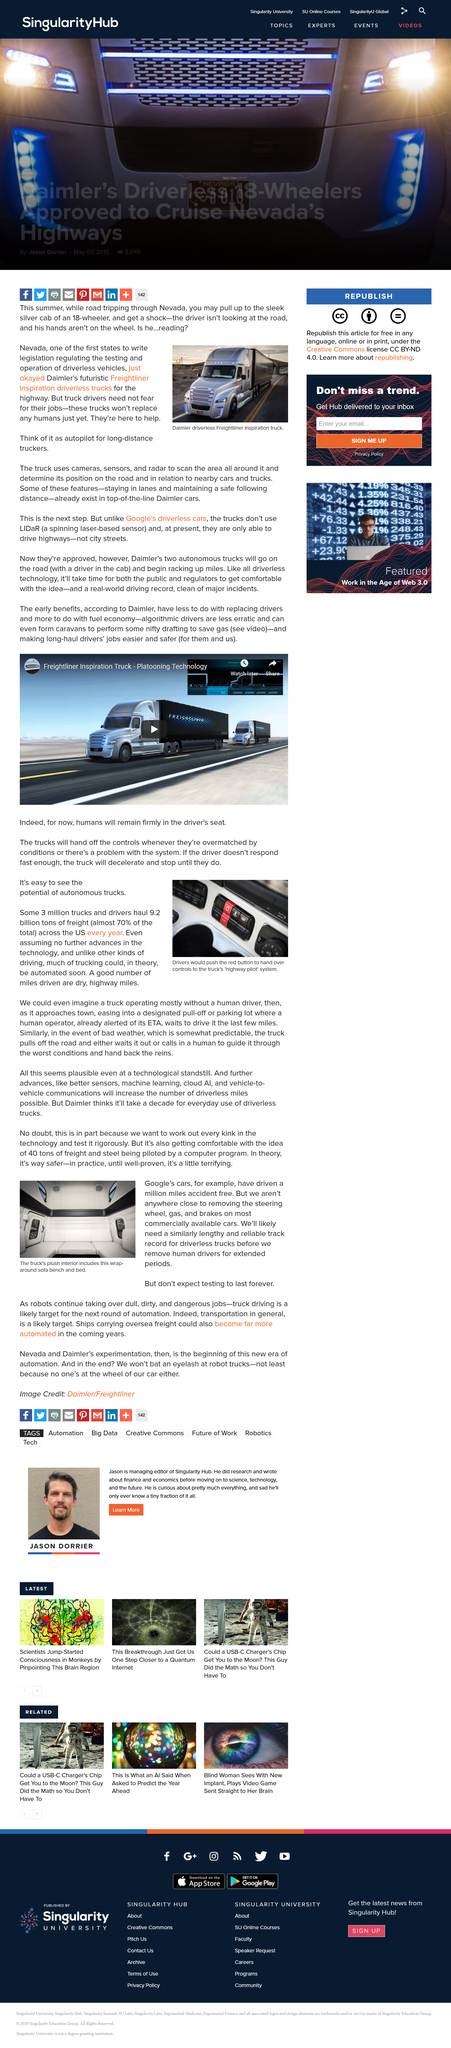Outline some significant characteristics in this image. The truck utilizes cameras, sensors, and radar to scan the area and gather valuable data for farmers. Yes, it is possible that a significant portion of trucking could be automated in the near future. The photo features a truck with a plush interior that includes a wrap-around sofa bench and bed, as indicated by the caption. Ships carrying overseas freight will likely become more automated in the coming years. The caption of the photo states that the drivers would push the red button to transfer control of the truck to the highway pilot system. 